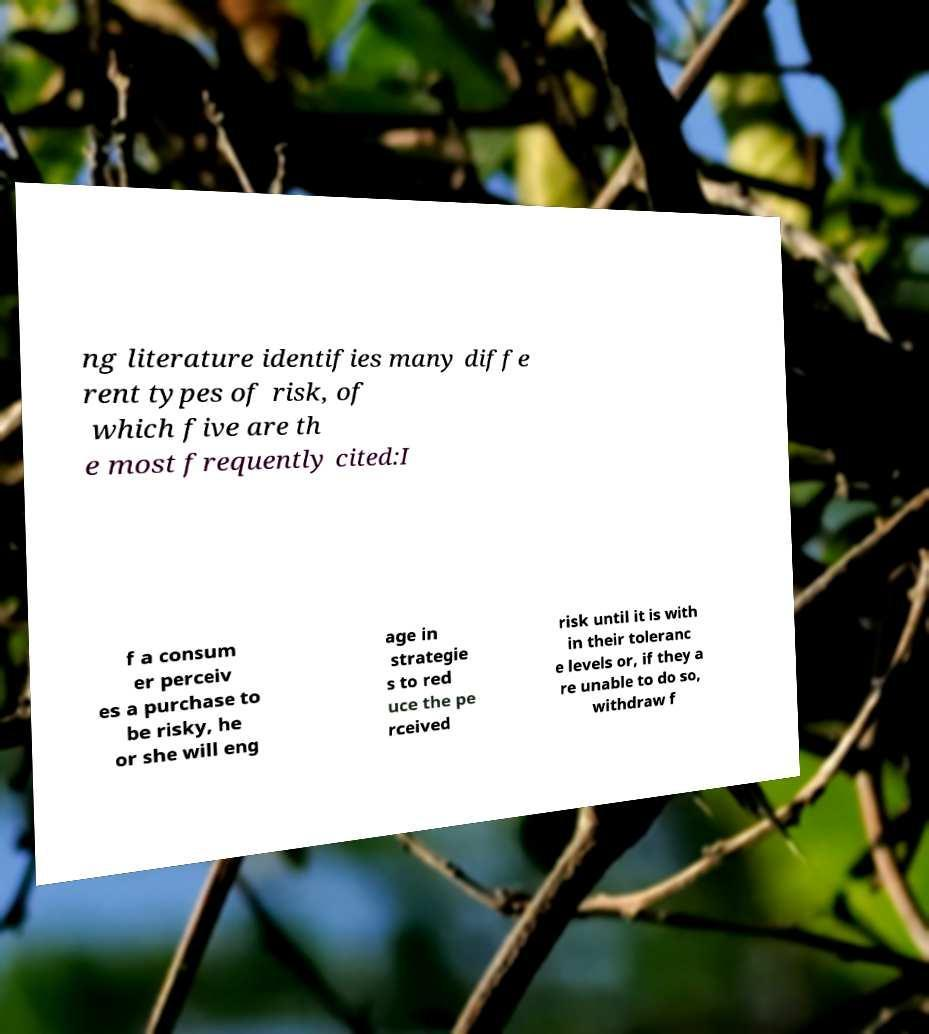I need the written content from this picture converted into text. Can you do that? ng literature identifies many diffe rent types of risk, of which five are th e most frequently cited:I f a consum er perceiv es a purchase to be risky, he or she will eng age in strategie s to red uce the pe rceived risk until it is with in their toleranc e levels or, if they a re unable to do so, withdraw f 